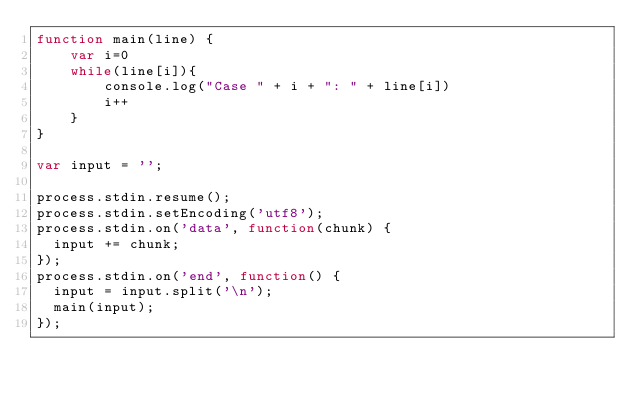Convert code to text. <code><loc_0><loc_0><loc_500><loc_500><_JavaScript_>function main(line) {
	var i=0
	while(line[i]){
		console.log("Case " + i + ": " + line[i])
		i++
	}
}

var input = '';

process.stdin.resume();
process.stdin.setEncoding('utf8');
process.stdin.on('data', function(chunk) {
  input += chunk;
});
process.stdin.on('end', function() {
  input = input.split('\n');
  main(input);
});</code> 